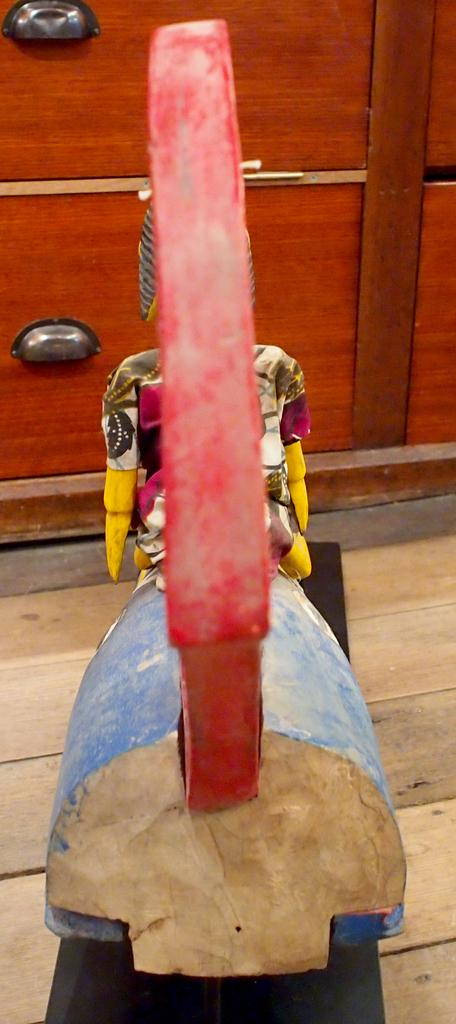What type of toy is in the image? There is a wooden horse in the image. Where is the wooden horse located in relation to other objects? The wooden horse is in front of a drawer. What type of ornament is hanging from the wooden horse in the image? There is no ornament hanging from the wooden horse in the image. 